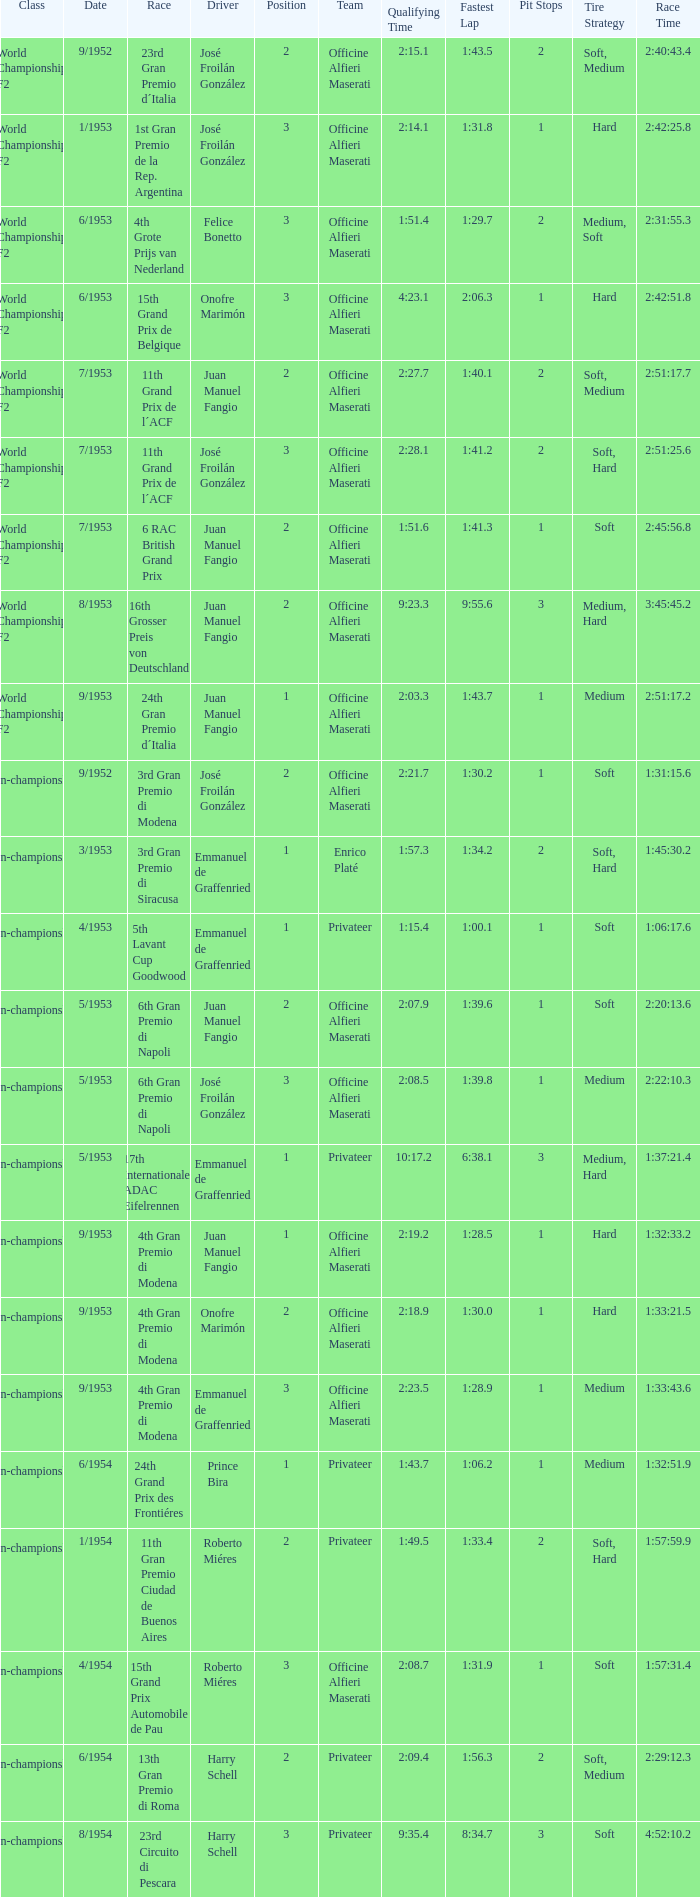What driver has a team of officine alfieri maserati and belongs to the class of non-championship f2 and has a position of 2, as well as a date of 9/1952? José Froilán González. Can you parse all the data within this table? {'header': ['Class', 'Date', 'Race', 'Driver', 'Position', 'Team', 'Qualifying Time', 'Fastest Lap', 'Pit Stops', 'Tire Strategy', 'Race Time'], 'rows': [['World Championship F2', '9/1952', '23rd Gran Premio d´Italia', 'José Froilán González', '2', 'Officine Alfieri Maserati', '2:15.1', '1:43.5', '2', 'Soft, Medium', '2:40:43.4'], ['World Championship F2', '1/1953', '1st Gran Premio de la Rep. Argentina', 'José Froilán González', '3', 'Officine Alfieri Maserati', '2:14.1', '1:31.8', '1', 'Hard', '2:42:25.8'], ['World Championship F2', '6/1953', '4th Grote Prijs van Nederland', 'Felice Bonetto', '3', 'Officine Alfieri Maserati', '1:51.4', '1:29.7', '2', 'Medium, Soft', '2:31:55.3'], ['World Championship F2', '6/1953', '15th Grand Prix de Belgique', 'Onofre Marimón', '3', 'Officine Alfieri Maserati', '4:23.1', '2:06.3', '1', 'Hard', '2:42:51.8'], ['World Championship F2', '7/1953', '11th Grand Prix de l´ACF', 'Juan Manuel Fangio', '2', 'Officine Alfieri Maserati', '2:27.7', '1:40.1', '2', 'Soft, Medium', '2:51:17.7'], ['World Championship F2', '7/1953', '11th Grand Prix de l´ACF', 'José Froilán González', '3', 'Officine Alfieri Maserati', '2:28.1', '1:41.2', '2', 'Soft, Hard', '2:51:25.6'], ['World Championship F2', '7/1953', '6 RAC British Grand Prix', 'Juan Manuel Fangio', '2', 'Officine Alfieri Maserati', '1:51.6', '1:41.3', '1', 'Soft', '2:45:56.8'], ['World Championship F2', '8/1953', '16th Grosser Preis von Deutschland', 'Juan Manuel Fangio', '2', 'Officine Alfieri Maserati', '9:23.3', '9:55.6', '3', 'Medium, Hard', '3:45:45.2'], ['World Championship F2', '9/1953', '24th Gran Premio d´Italia', 'Juan Manuel Fangio', '1', 'Officine Alfieri Maserati', '2:03.3', '1:43.7', '1', 'Medium', '2:51:17.2'], ['Non-championship F2', '9/1952', '3rd Gran Premio di Modena', 'José Froilán González', '2', 'Officine Alfieri Maserati', '2:21.7', '1:30.2', '1', 'Soft', '1:31:15.6'], ['Non-championship F2', '3/1953', '3rd Gran Premio di Siracusa', 'Emmanuel de Graffenried', '1', 'Enrico Platé', '1:57.3', '1:34.2', '2', 'Soft, Hard', '1:45:30.2'], ['Non-championship F2', '4/1953', '5th Lavant Cup Goodwood', 'Emmanuel de Graffenried', '1', 'Privateer', '1:15.4', '1:00.1', '1', 'Soft', '1:06:17.6'], ['Non-championship F2', '5/1953', '6th Gran Premio di Napoli', 'Juan Manuel Fangio', '2', 'Officine Alfieri Maserati', '2:07.9', '1:39.6', '1', 'Soft', '2:20:13.6'], ['Non-championship F2', '5/1953', '6th Gran Premio di Napoli', 'José Froilán González', '3', 'Officine Alfieri Maserati', '2:08.5', '1:39.8', '1', 'Medium', '2:22:10.3'], ['Non-championship F2', '5/1953', '17th Internationales ADAC Eifelrennen', 'Emmanuel de Graffenried', '1', 'Privateer', '10:17.2', '6:38.1', '3', 'Medium, Hard', '1:37:21.4'], ['Non-championship F2', '9/1953', '4th Gran Premio di Modena', 'Juan Manuel Fangio', '1', 'Officine Alfieri Maserati', '2:19.2', '1:28.5', '1', 'Hard', '1:32:33.2'], ['Non-championship F2', '9/1953', '4th Gran Premio di Modena', 'Onofre Marimón', '2', 'Officine Alfieri Maserati', '2:18.9', '1:30.0', '1', 'Hard', '1:33:21.5'], ['Non-championship F2', '9/1953', '4th Gran Premio di Modena', 'Emmanuel de Graffenried', '3', 'Officine Alfieri Maserati', '2:23.5', '1:28.9', '1', 'Medium', '1:33:43.6'], ['(Non-championship) F2', '6/1954', '24th Grand Prix des Frontiéres', 'Prince Bira', '1', 'Privateer', '1:43.7', '1:06.2', '1', 'Medium', '1:32:51.9'], ['Non-championship F1', '1/1954', '11th Gran Premio Ciudad de Buenos Aires', 'Roberto Miéres', '2', 'Privateer', '1:49.5', '1:33.4', '2', 'Soft, Hard', '1:57:59.9'], ['Non-championship F1', '4/1954', '15th Grand Prix Automobile de Pau', 'Roberto Miéres', '3', 'Officine Alfieri Maserati', '2:08.7', '1:31.9', '1', 'Soft', '1:57:31.4'], ['Non-championship F1', '6/1954', '13th Gran Premio di Roma', 'Harry Schell', '2', 'Privateer', '2:09.4', '1:56.3', '2', 'Soft, Medium', '2:29:12.3'], ['Non-championship F1', '8/1954', '23rd Circuito di Pescara', 'Harry Schell', '3', 'Privateer', '9:35.4', '8:34.7', '3', 'Soft', '4:52:10.2']]} 